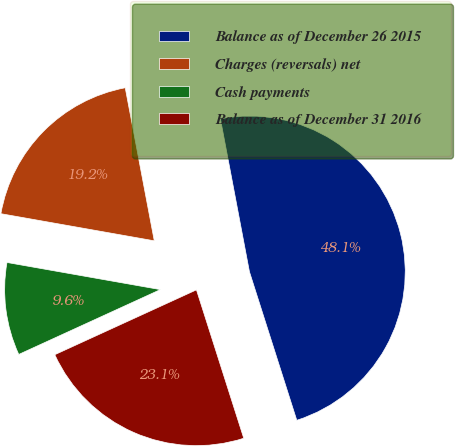<chart> <loc_0><loc_0><loc_500><loc_500><pie_chart><fcel>Balance as of December 26 2015<fcel>Charges (reversals) net<fcel>Cash payments<fcel>Balance as of December 31 2016<nl><fcel>48.08%<fcel>19.23%<fcel>9.62%<fcel>23.08%<nl></chart> 